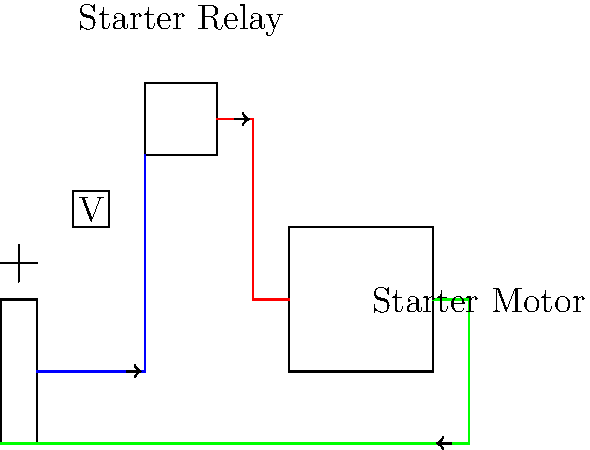In a dirt bike's starting system, you notice that the starter motor doesn't engage when the start button is pressed. Using a voltmeter, you measure 12V at the battery terminals but 0V at the starter motor input. What component in the starting system is most likely faulty? To diagnose the issue in the dirt bike's starting system, let's follow these steps:

1. First, we confirm that the battery is functioning correctly, as we measure 12V at its terminals.

2. The starting system typically consists of the following main components:
   - Battery
   - Starter button
   - Starter relay (also called solenoid)
   - Starter motor

3. The current flow in a properly functioning system should be:
   Battery → Starter button → Starter relay → Starter motor → Ground

4. Since we have voltage at the battery but not at the starter motor, the issue lies somewhere in between these components.

5. The starter relay is the most likely culprit because:
   - It's responsible for connecting the high-current circuit between the battery and starter motor when activated by the low-current circuit from the starter button.
   - If it fails, it won't complete the circuit, resulting in no voltage at the starter motor.

6. To confirm this diagnosis:
   - Check for 12V at the input of the starter relay when the start button is pressed.
   - If 12V is present at the input but not at the output when the button is pressed, the starter relay is faulty.

7. Other possibilities like a broken wire or faulty starter button are less likely because they would typically result in an open circuit, which we can rule out by the voltage readings.

Therefore, based on the symptoms and the typical failure modes in a starting system, the starter relay is the most likely faulty component.
Answer: Starter relay 